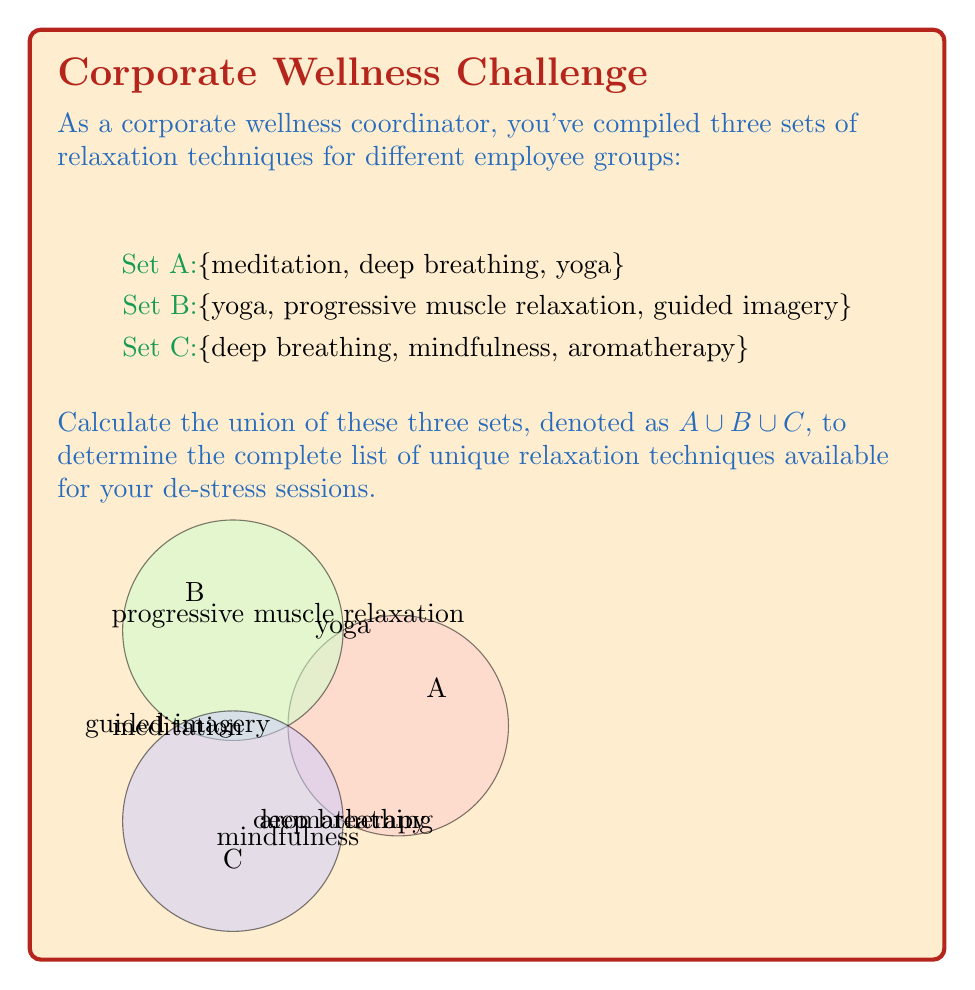Solve this math problem. To find the union of sets A, B, and C, we need to list all unique elements that appear in at least one of the sets. Let's approach this step-by-step:

1) First, let's list all elements from set A:
   {meditation, deep breathing, yoga}

2) Now, let's add any new elements from set B that are not already in our list:
   - yoga is already included
   - We add: progressive muscle relaxation, guided imagery
   Current list: {meditation, deep breathing, yoga, progressive muscle relaxation, guided imagery}

3) Finally, let's add any new elements from set C that are not already in our list:
   - deep breathing is already included
   - We add: mindfulness, aromatherapy
   
4) Our final list of unique elements is:
   {meditation, deep breathing, yoga, progressive muscle relaxation, guided imagery, mindfulness, aromatherapy}

This list represents $A \cup B \cup C$, which is the union of all three sets.

In set notation, we can write this as:

$$A \cup B \cup C = \{meditation, deep breathing, yoga, progressive muscle relaxation, guided imagery, mindfulness, aromatherapy\}$$

The union contains 7 unique relaxation techniques.
Answer: $$\{meditation, deep breathing, yoga, progressive muscle relaxation, guided imagery, mindfulness, aromatherapy\}$$ 